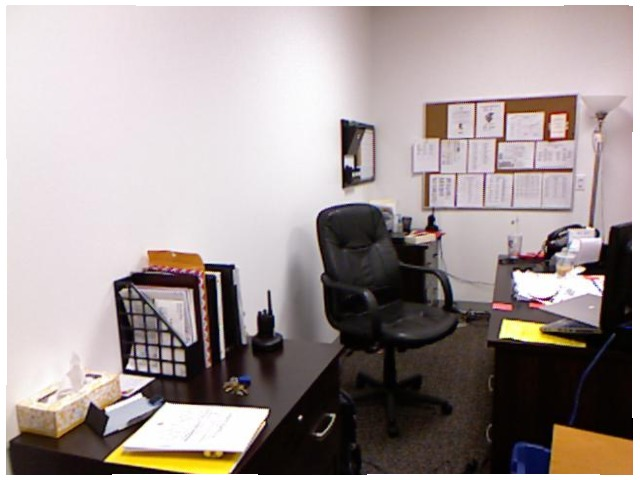<image>
Is the chair in front of the tissue box? No. The chair is not in front of the tissue box. The spatial positioning shows a different relationship between these objects. Where is the walkie talkie in relation to the chair? Is it to the right of the chair? Yes. From this viewpoint, the walkie talkie is positioned to the right side relative to the chair. Is there a chair to the right of the wall? Yes. From this viewpoint, the chair is positioned to the right side relative to the wall. Where is the telephone in relation to the cup? Is it to the right of the cup? No. The telephone is not to the right of the cup. The horizontal positioning shows a different relationship. Is the radio under the chair? No. The radio is not positioned under the chair. The vertical relationship between these objects is different. Is there a paper next to the chair? Yes. The paper is positioned adjacent to the chair, located nearby in the same general area. Is the chair behind the table? Yes. From this viewpoint, the chair is positioned behind the table, with the table partially or fully occluding the chair. 